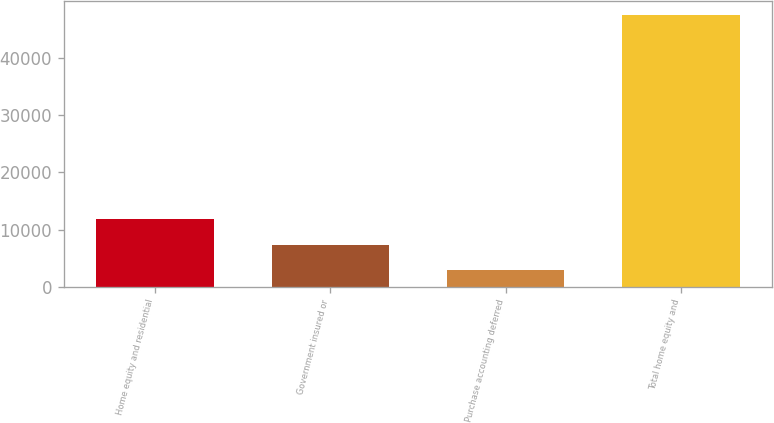Convert chart to OTSL. <chart><loc_0><loc_0><loc_500><loc_500><bar_chart><fcel>Home equity and residential<fcel>Government insured or<fcel>Purchase accounting deferred<fcel>Total home equity and<nl><fcel>11810<fcel>7341.5<fcel>2873<fcel>47558<nl></chart> 